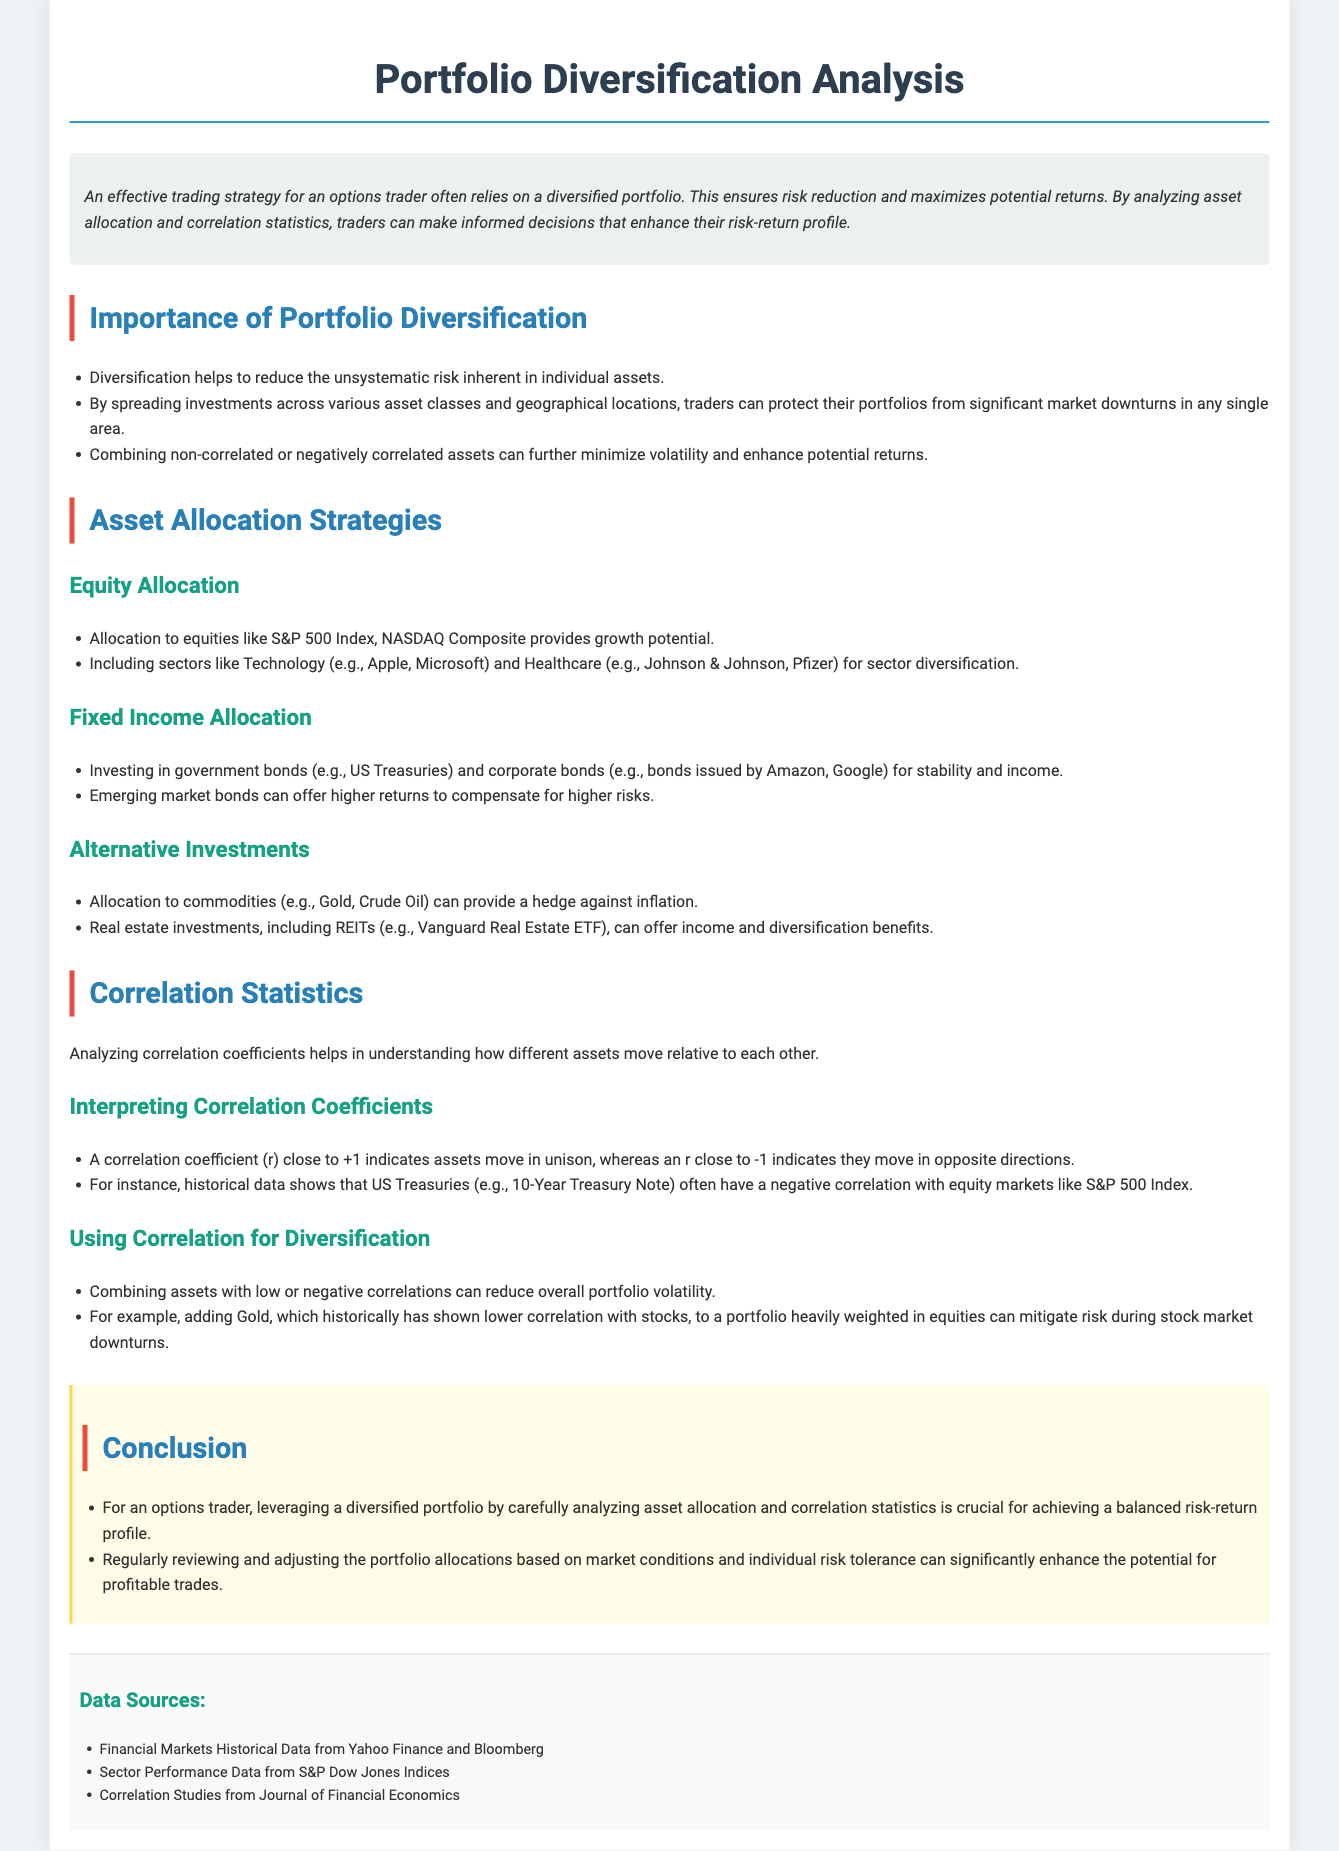what is the main benefit of portfolio diversification? The main benefit of portfolio diversification is to reduce the unsystematic risk inherent in individual assets.
Answer: reduce the unsystematic risk which index provides growth potential in equity allocation? The S&P 500 Index is mentioned as providing growth potential in equity allocation.
Answer: S&P 500 Index name one type of alternative investment listed. The document lists commodities as a type of alternative investment.
Answer: commodities what does a correlation coefficient close to +1 indicate? A correlation coefficient close to +1 indicates assets move in unison.
Answer: assets move in unison what is the category of bonds that provide stability and income? Fixed income allocation includes government bonds that provide stability and income.
Answer: Fixed income name one sector included for sector diversification in equity allocation. The Technology sector is included for sector diversification in equity allocation.
Answer: Technology how can adding Gold to a portfolio benefit an options trader? Adding Gold can mitigate risk during stock market downturns due to its lower correlation with stocks.
Answer: mitigate risk which document section discusses the importance of diversifying investments? The section titled "Importance of Portfolio Diversification" discusses diversifying investments.
Answer: Importance of Portfolio Diversification which data source provides historical data from financial markets? Financial Markets Historical Data from Yahoo Finance and Bloomberg is a listed data source.
Answer: Yahoo Finance and Bloomberg 